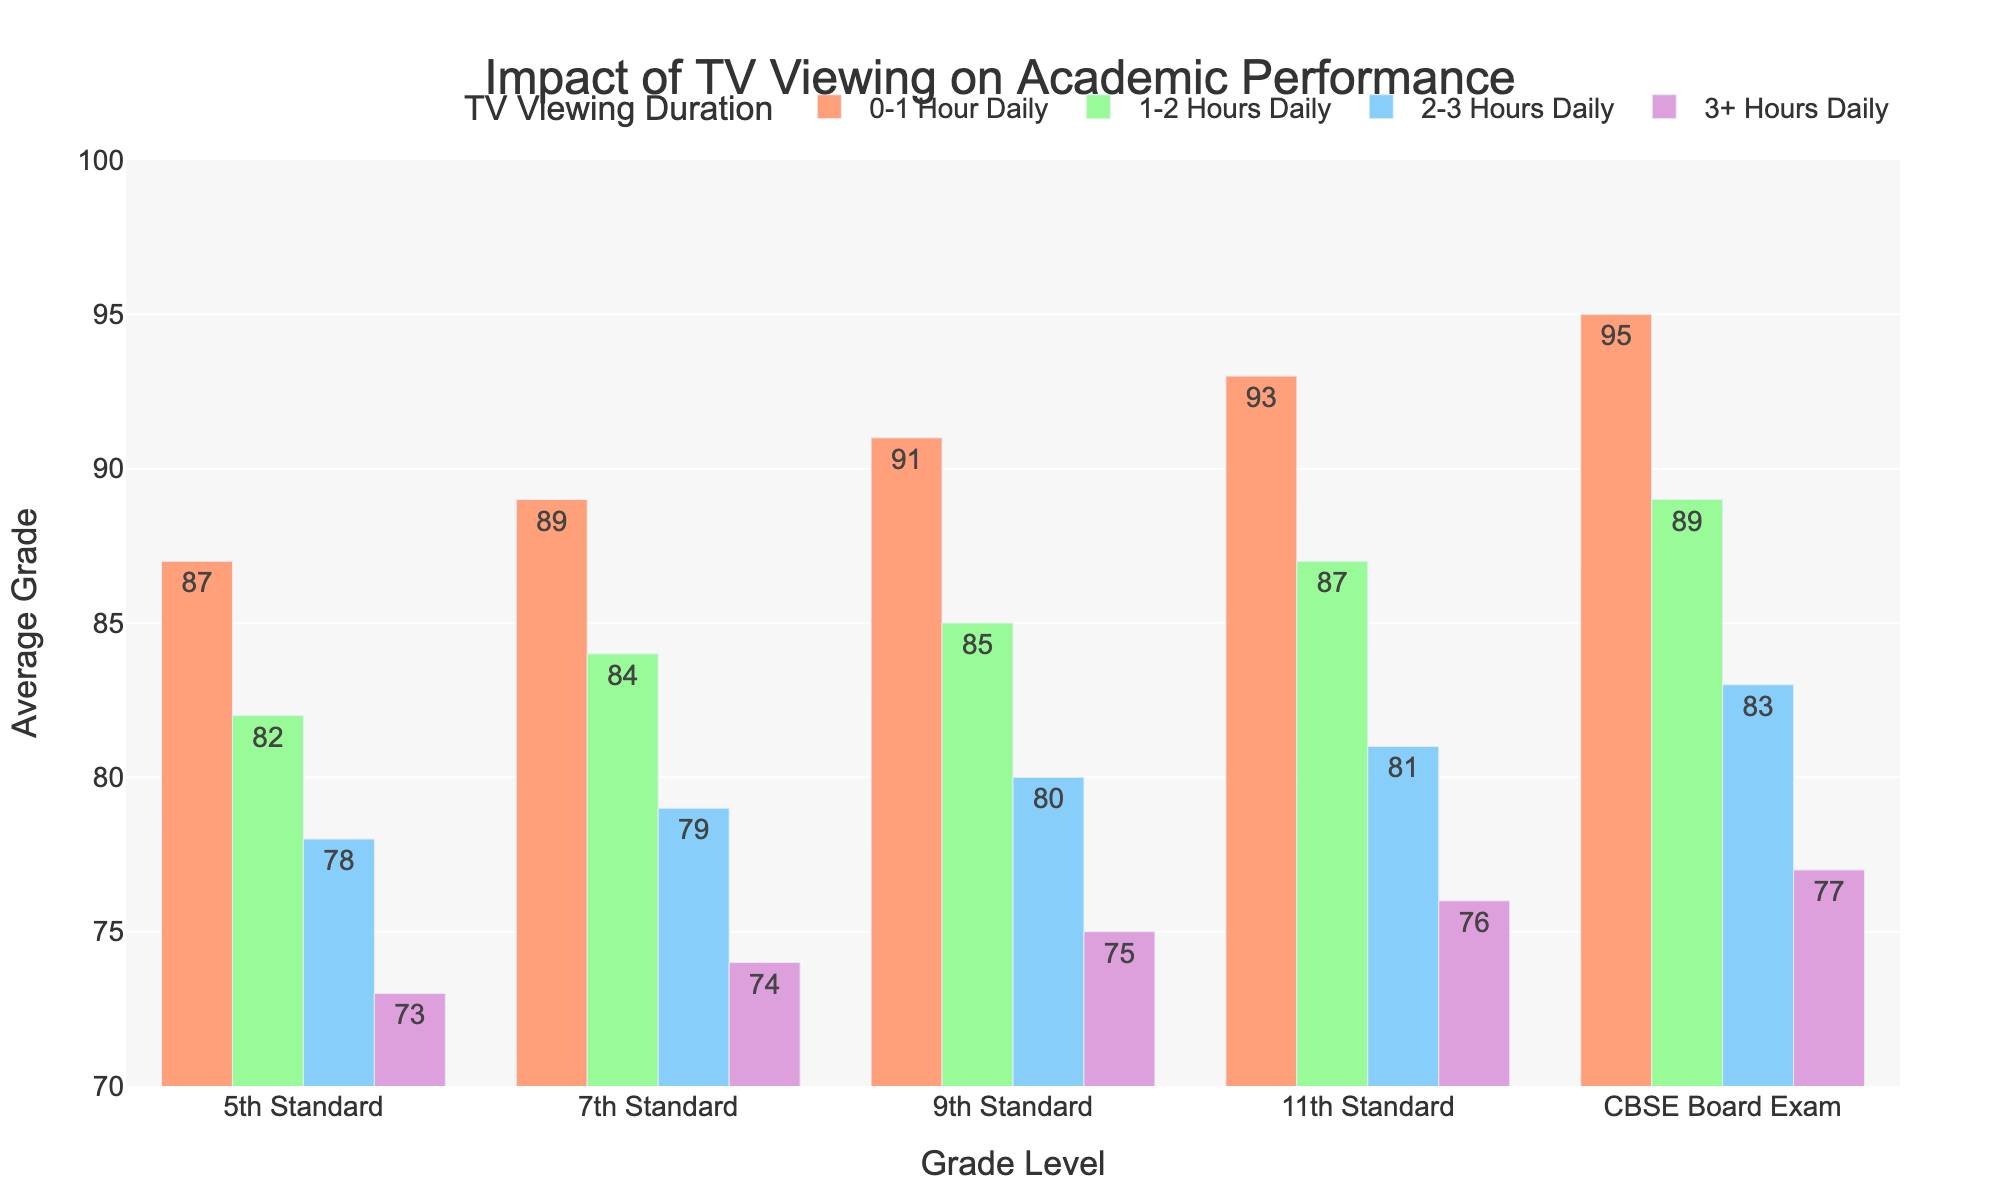What is the average grade for 7th Standard students who watch 2-3 hours of TV daily? For 7th Standard, the average grade for students who watch 2-3 hours of TV daily is listed directly in the figure. It's 79.
Answer: 79 How does the average grade of 3+ Hours Daily group in 11th Standard compare to the 0-1 Hour Daily group in CBSE Board Exam? According to the figure, the 3+ Hours Daily group in 11th Standard has an average grade of 76, while the 0-1 Hour Daily group in CBSE Board Exam has an average grade of 95.
Answer: 76 vs 95 Which grade level sees the largest drop in average grade from the 0-1 Hour Daily to the 3+ Hours Daily group? The largest drop can be calculated by subtracting the 3+ Hours Daily grade from the 0-1 Hour Daily grade for each grade level and finding the maximum difference. For 5th Standard: 87 - 73 = 14, 7th Standard: 89 - 74 = 15, 9th Standard: 91 - 75 = 16, 11th Standard: 93 - 76 = 17, CBSE Board Exam: 95 - 77 = 18. The largest drop is observed in the CBSE Board Exam.
Answer: CBSE Board Exam Which TV viewing duration group generally has the highest average grades across all grade levels? By examining the figure, the 0-1 Hour Daily group consistently has the highest average grades across all grade levels.
Answer: 0-1 Hour Daily What is the total average grade for all students in the 2-3 Hours Daily group across all grade levels? To find the total average grade for the 2-3 Hours Daily group, sum the average grades for each level and then compute the average: (78 + 79 + 80 + 81 + 83)/5 = 401/5 = 80.2.
Answer: 80.2 How does the average grade of 9th Standard students watching 1-2 hours of TV daily compare to those watching 3+ hours daily? For 9th Standard students, those watching 1-2 hours of TV daily have an average grade of 85, while those watching 3+ hours daily have an average grade of 75.
Answer: 85 vs 75 What is the overall trend in average grades as TV watching duration increases for any given grade level? The overall trend is that average grades decrease as TV watching duration increases for any given grade level.
Answer: Decrease What is the approximate difference in average grade between the 1-2 Hours Daily group and the 3+ Hours Daily group in 7th Standard? The approximate difference can be found by subtracting the 3+ Hours Daily grade from the 1-2 Hours Daily grade: 84 - 74 = 10.
Answer: 10 What color represents the 2-3 Hours Daily TV viewing duration group in the figure? In the figure, the 2-3 Hours Daily TV viewing duration group is represented by the color blue.
Answer: Blue What percentage drop in average grade is seen from the 0-1 Hour Daily group to the 2-3 Hours Daily group in the CBSE Board Exam? Calculate the percentage drop by dividing the difference between the two grades by the grade for the 0-1 Hour Daily group, then multiply by 100: ((95 - 83) / 95) * 100 = 12.63%.
Answer: 12.63% 